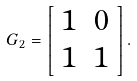<formula> <loc_0><loc_0><loc_500><loc_500>G _ { 2 } = \left [ \begin{array} { c c } 1 & 0 \\ 1 & 1 \end{array} \right ] .</formula> 